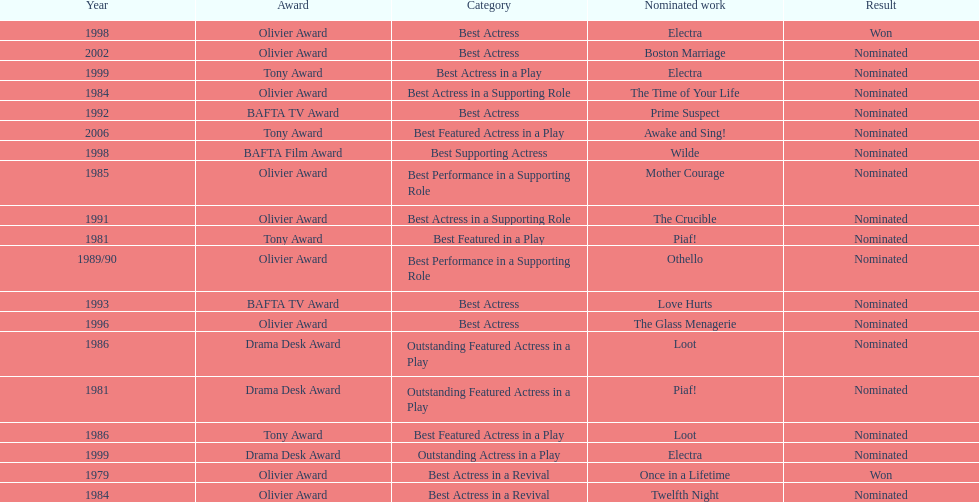What play was wanamaker nominated for best actress in a revival in 1984? Twelfth Night. 